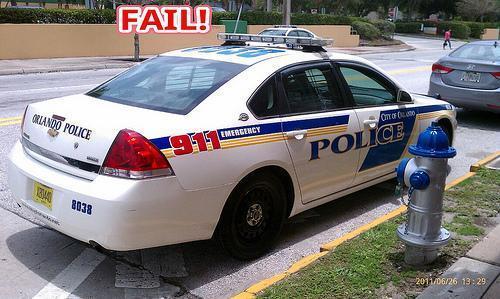How many passenger doors are there on the police car?
Give a very brief answer. 4. 